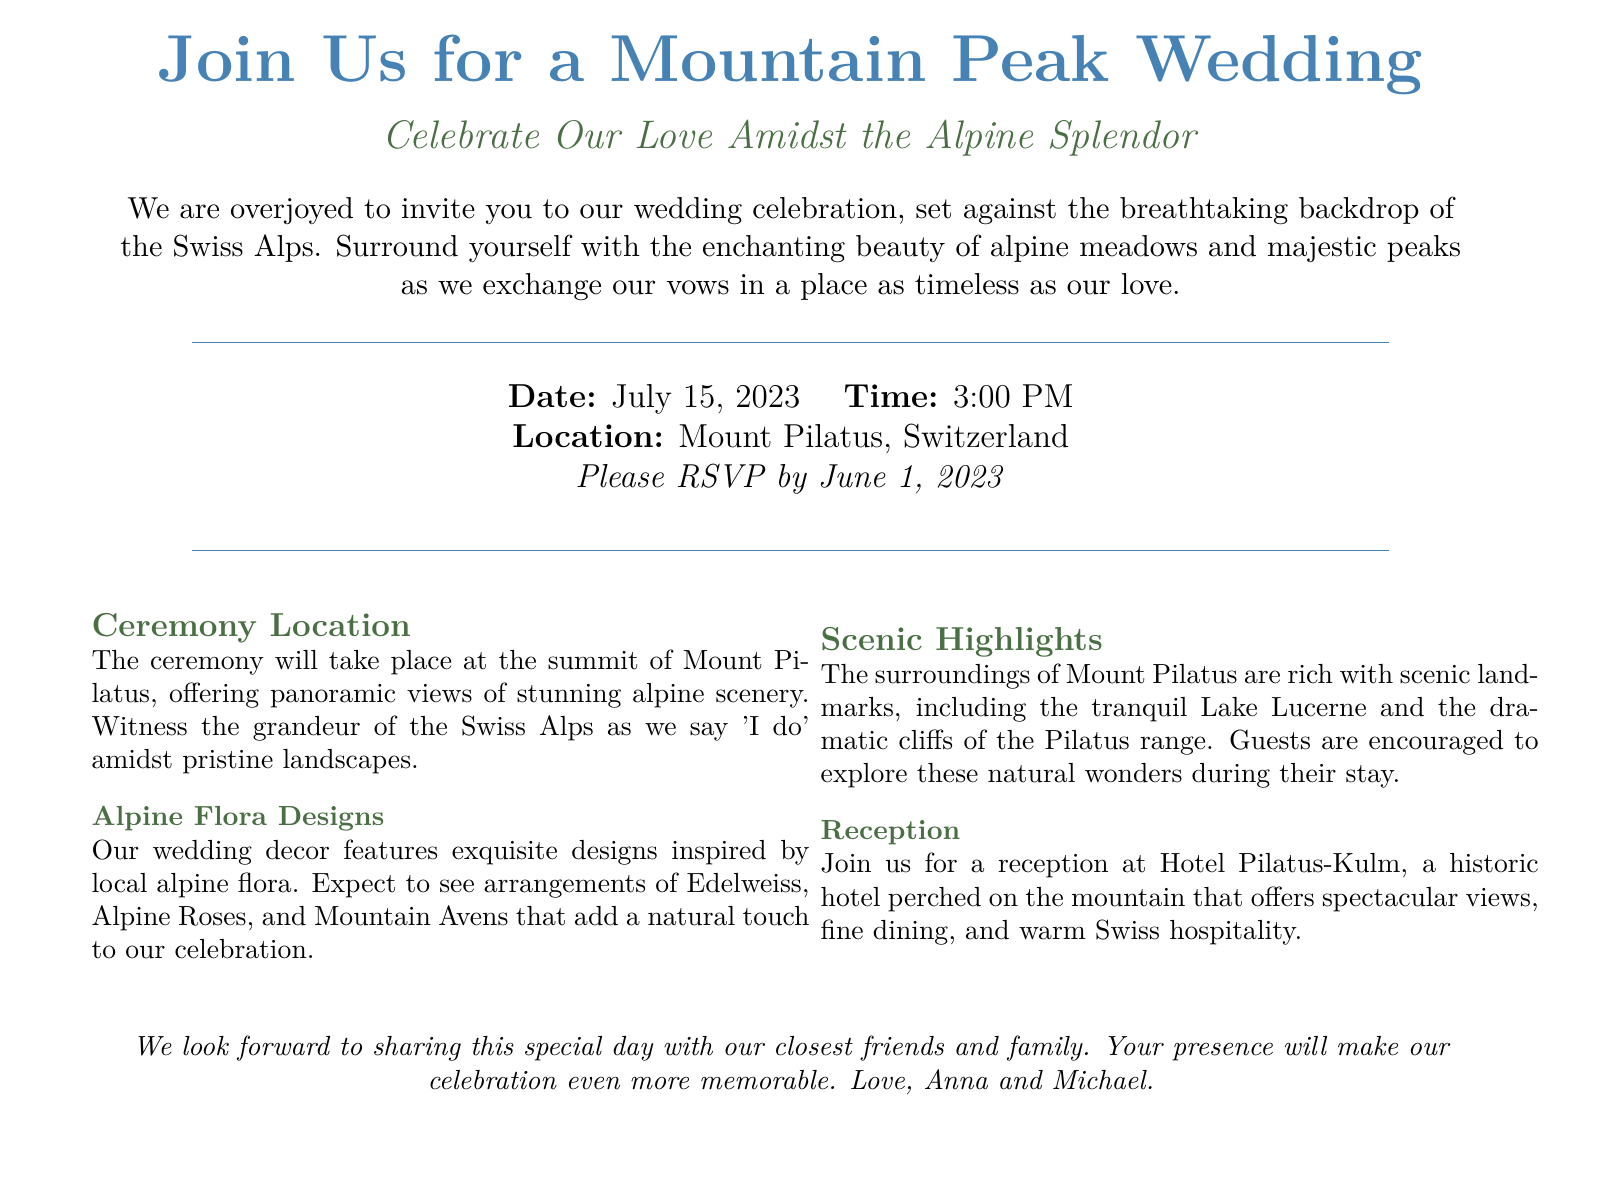What is the date of the wedding? The date of the wedding is explicitly mentioned in the document as July 15, 2023.
Answer: July 15, 2023 Where will the ceremony take place? The location of the ceremony is specified in the document as Mount Pilatus, Switzerland.
Answer: Mount Pilatus, Switzerland What flowers will be featured in the wedding decor? The document lists specific flowers included in the decor, such as Edelweiss, Alpine Roses, and Mountain Avens.
Answer: Edelweiss, Alpine Roses, Mountain Avens What is the time of the wedding ceremony? The document states the time of the ceremony is at 3:00 PM.
Answer: 3:00 PM What scenic features are highlighted in the invitation? The document mentions scenic landmarks such as Lake Lucerne and the cliffs of the Pilatus range as highlights.
Answer: Lake Lucerne, cliffs of the Pilatus range Who are the couple getting married? The document provides the names of the couple, which are noted at the end.
Answer: Anna and Michael When is the RSVP deadline? The deadline for RSVPs is clearly stated in the document as June 1, 2023.
Answer: June 1, 2023 What type of venue is the reception held at? The document describes the reception venue as a historic hotel.
Answer: Hotel Pilatus-Kulm What is the main theme of the wedding? The document emphasizes that the celebration is set against a mountain peak backdrop amidst alpine splendor.
Answer: Alpine Splendor 